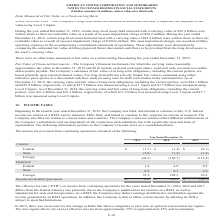According to American Tower Corporation's financial document, What was the deferred Federal Income tax benefit (provision) in 2017? According to the financial document, 0.2 (in millions). The relevant text states: "Federal 1.4 4.0 0.2..." Also, What do the company's state tax returns reflect? different combinations of the Company’s subsidiaries and are dependent on the connection each subsidiary has with a particular state and form of organization.. The document states: "countries. The Company’s state tax returns reflect different combinations of the Company’s subsidiaries and are dependent on the connection each subsi..." Also, What was the deferred Foreign income tax provision in 2019? According to the financial document, 53.2 (in millions). The relevant text states: "Foreign 53.2 298.3 85.4..." Also, How many of the deferred Income tax benefit (provision) were above $50 million in 2017? Based on the analysis, there are 1 instances. The counting process: Foreign. Also, How many of the current Income tax benefit (provision) were above $(4 million) in 2019? Counting the relevant items in the document: Foreign, State, I find 2 instances. The key data points involved are: Foreign, State. Also, can you calculate: What was the percentage change in Income tax benefit (provision) between 2018 and 2019? To answer this question, I need to perform calculations using the financial data. The calculation is: ($0.2-$110.1)/$110.1, which equals -99.82 (percentage). This is based on the information: "Federal 1.4 4.0 0.2 Income tax benefit (provision) $ 0.2 $ 110.1 $ (30.7)..." The key data points involved are: 0.2, 110.1. 